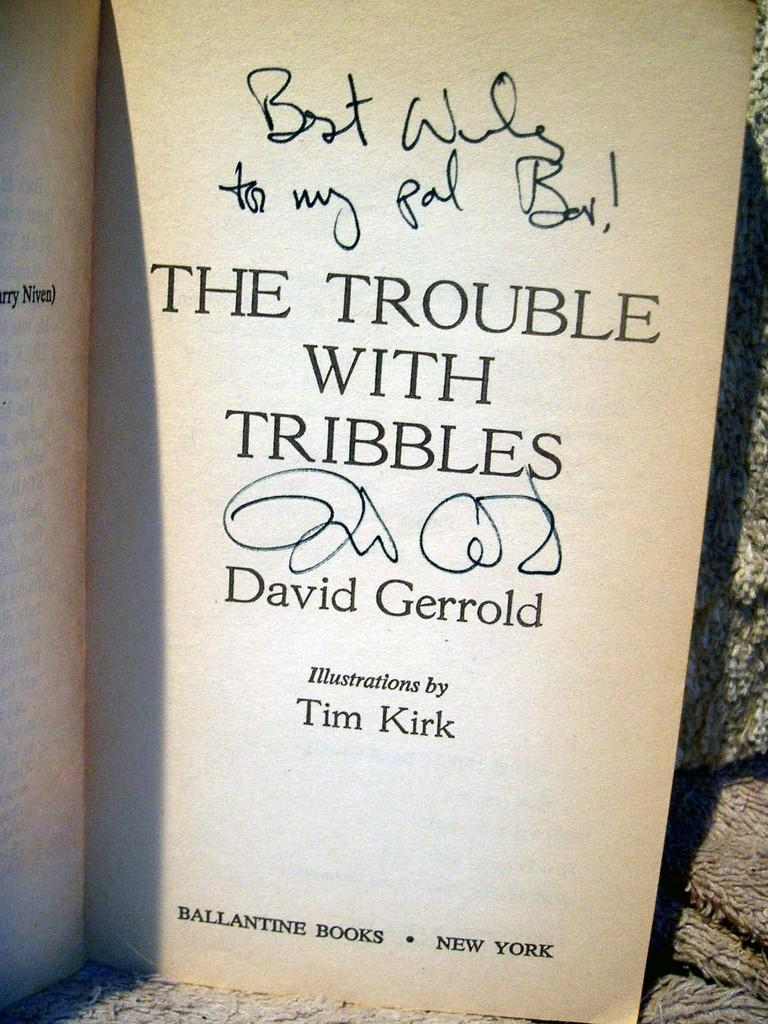<image>
Present a compact description of the photo's key features. David Gerrold signed a copy of his book, "The Trouble with Tribbles." 